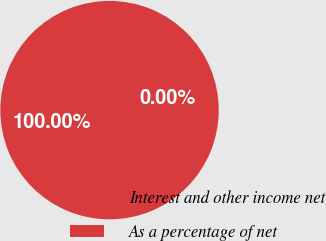Convert chart. <chart><loc_0><loc_0><loc_500><loc_500><pie_chart><fcel>Interest and other income net<fcel>As a percentage of net<nl><fcel>100.0%<fcel>0.0%<nl></chart> 